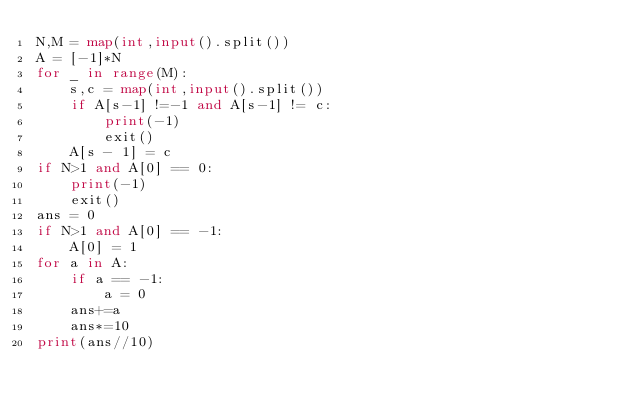<code> <loc_0><loc_0><loc_500><loc_500><_Python_>N,M = map(int,input().split())
A = [-1]*N
for _ in range(M):
    s,c = map(int,input().split())
    if A[s-1] !=-1 and A[s-1] != c:
        print(-1)
        exit()
    A[s - 1] = c
if N>1 and A[0] == 0:
    print(-1)
    exit()
ans = 0
if N>1 and A[0] == -1:
    A[0] = 1
for a in A:
    if a == -1:
        a = 0
    ans+=a
    ans*=10
print(ans//10)
        
    
    


    
    
        
</code> 